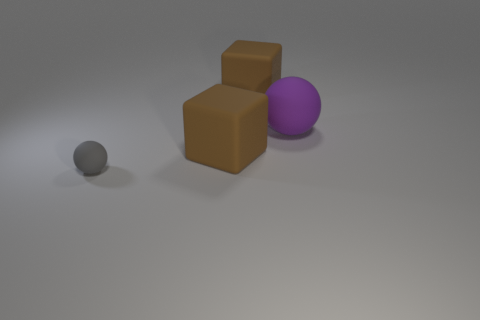There is a matte sphere behind the rubber block in front of the big ball; how big is it?
Your answer should be compact. Large. What number of objects are both behind the small gray object and to the left of the large purple rubber thing?
Offer a very short reply. 2. There is a gray matte sphere in front of the brown object that is behind the large purple ball; are there any purple rubber things in front of it?
Offer a terse response. No. Is there a large rubber object of the same color as the tiny ball?
Keep it short and to the point. No. Is the shape of the gray matte thing the same as the large purple rubber thing?
Give a very brief answer. Yes. What number of big things are matte balls or blocks?
Make the answer very short. 3. What is the color of the small sphere that is made of the same material as the big purple thing?
Keep it short and to the point. Gray. How many small gray spheres are made of the same material as the large sphere?
Your answer should be very brief. 1. Do the brown matte thing behind the big purple rubber thing and the gray rubber thing that is in front of the large purple thing have the same size?
Your answer should be very brief. No. What is the material of the brown thing behind the big brown cube in front of the big purple ball?
Your answer should be compact. Rubber. 